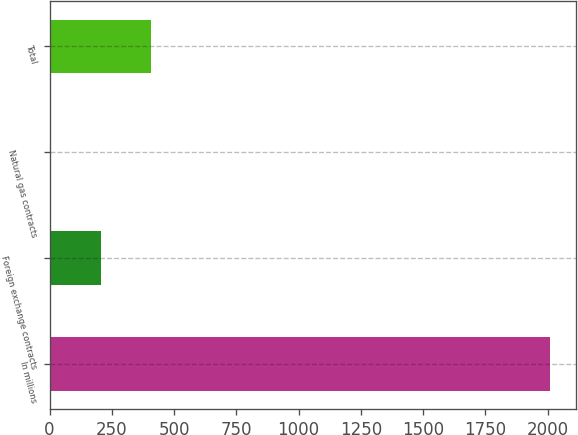Convert chart to OTSL. <chart><loc_0><loc_0><loc_500><loc_500><bar_chart><fcel>In millions<fcel>Foreign exchange contracts<fcel>Natural gas contracts<fcel>Total<nl><fcel>2011<fcel>206.5<fcel>6<fcel>407<nl></chart> 